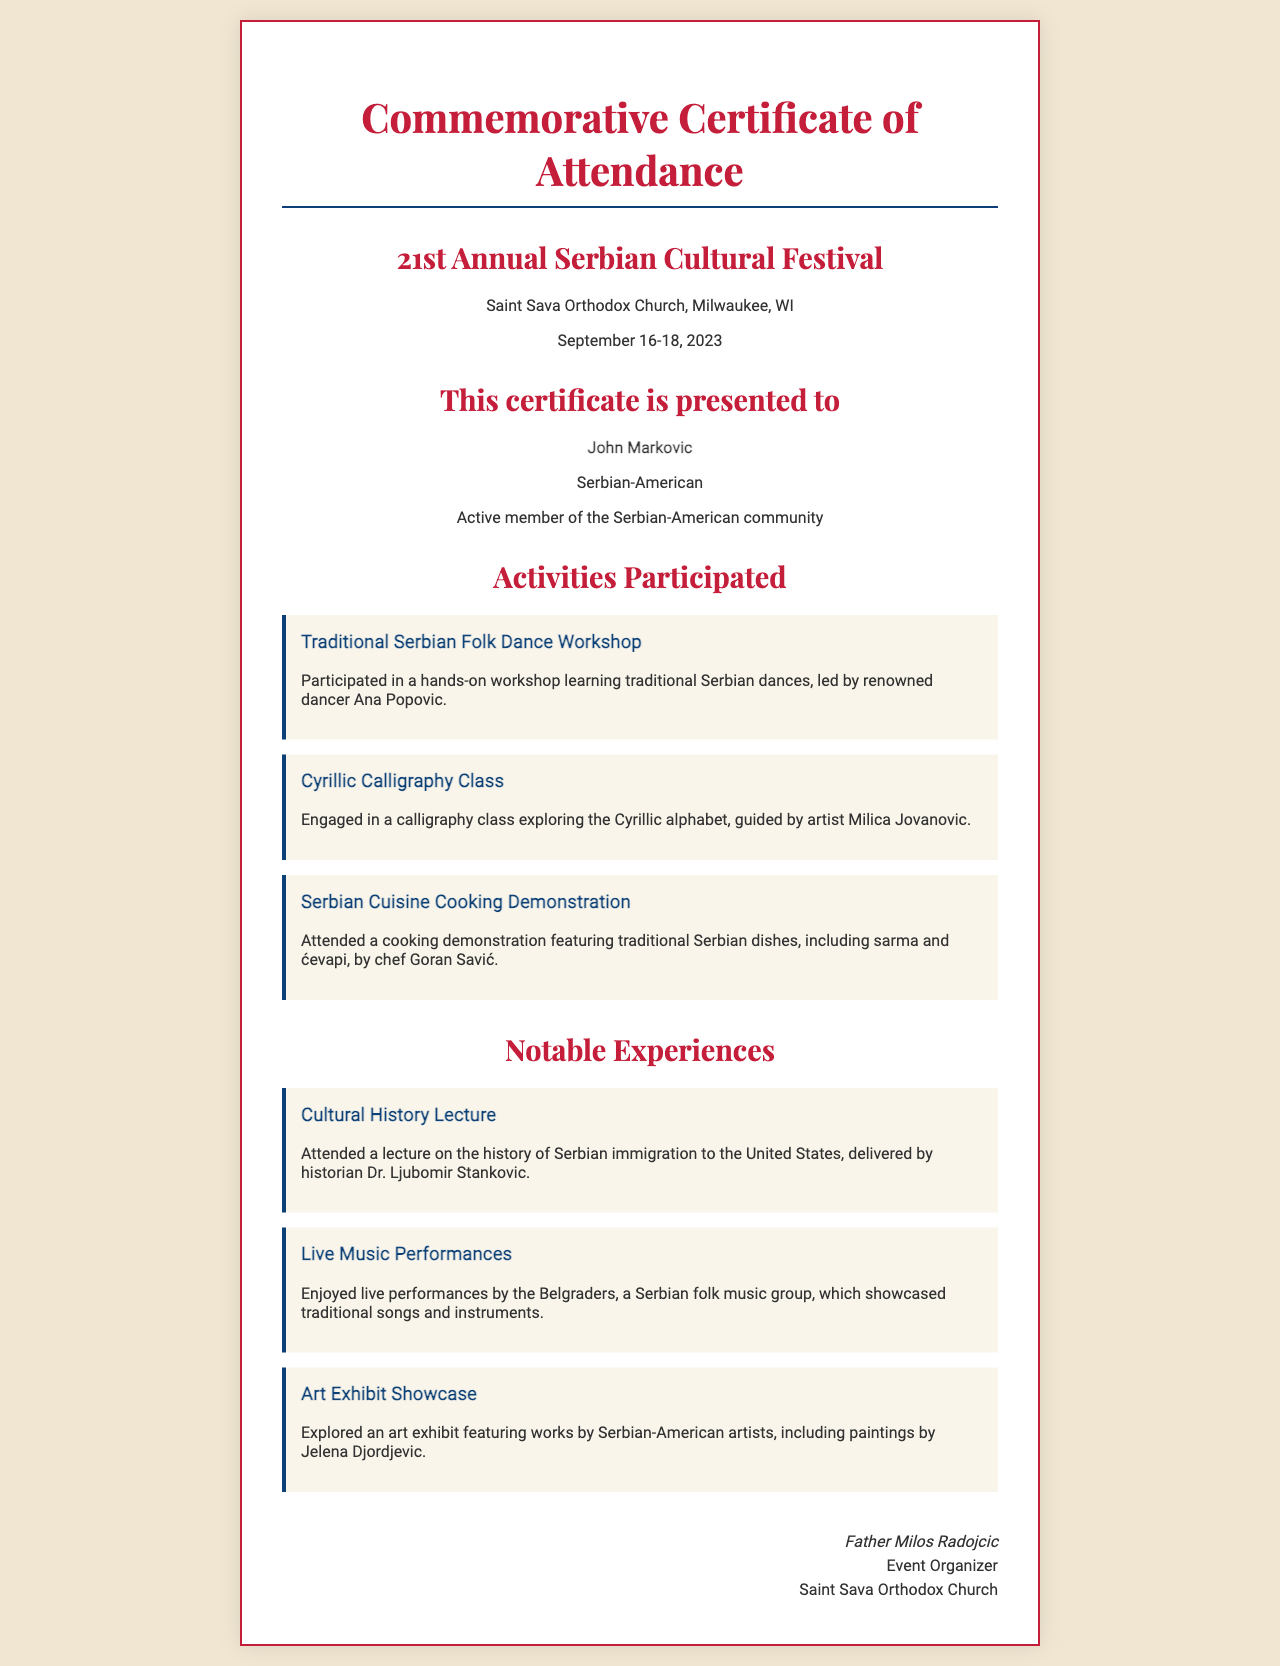What is the name of the festival? The name of the festival is mentioned as the "21st Annual Serbian Cultural Festival."
Answer: 21st Annual Serbian Cultural Festival Where was the festival held? The location of the festival is provided in the document, indicating it took place at "Saint Sava Orthodox Church, Milwaukee, WI."
Answer: Saint Sava Orthodox Church, Milwaukee, WI Who received the certificate? The certificate specifies the recipient's name as "John Markovic."
Answer: John Markovic What types of cultural activities were participated in? The document lists various activities, including a "Traditional Serbian Folk Dance Workshop," "Cyrillic Calligraphy Class," and "Serbian Cuisine Cooking Demonstration."
Answer: Traditional Serbian Folk Dance Workshop, Cyrillic Calligraphy Class, Serbian Cuisine Cooking Demonstration What notable experience involved a musician group? The document describes an experience involving "live performances by the Belgraders."
Answer: Belgraders Who delivered the cultural history lecture? The certificate provides the name of the lecturer as "Dr. Ljubomir Stankovic."
Answer: Dr. Ljubomir Stankovic What dish was featured in the cooking demonstration? The document specifies traditional dishes such as "sarma and ćevapi" that were demonstrated.
Answer: sarma and ćevapi Who signed the certificate? The signature section of the document indicates that it was signed by "Father Milos Radojcic."
Answer: Father Milos Radojcic 